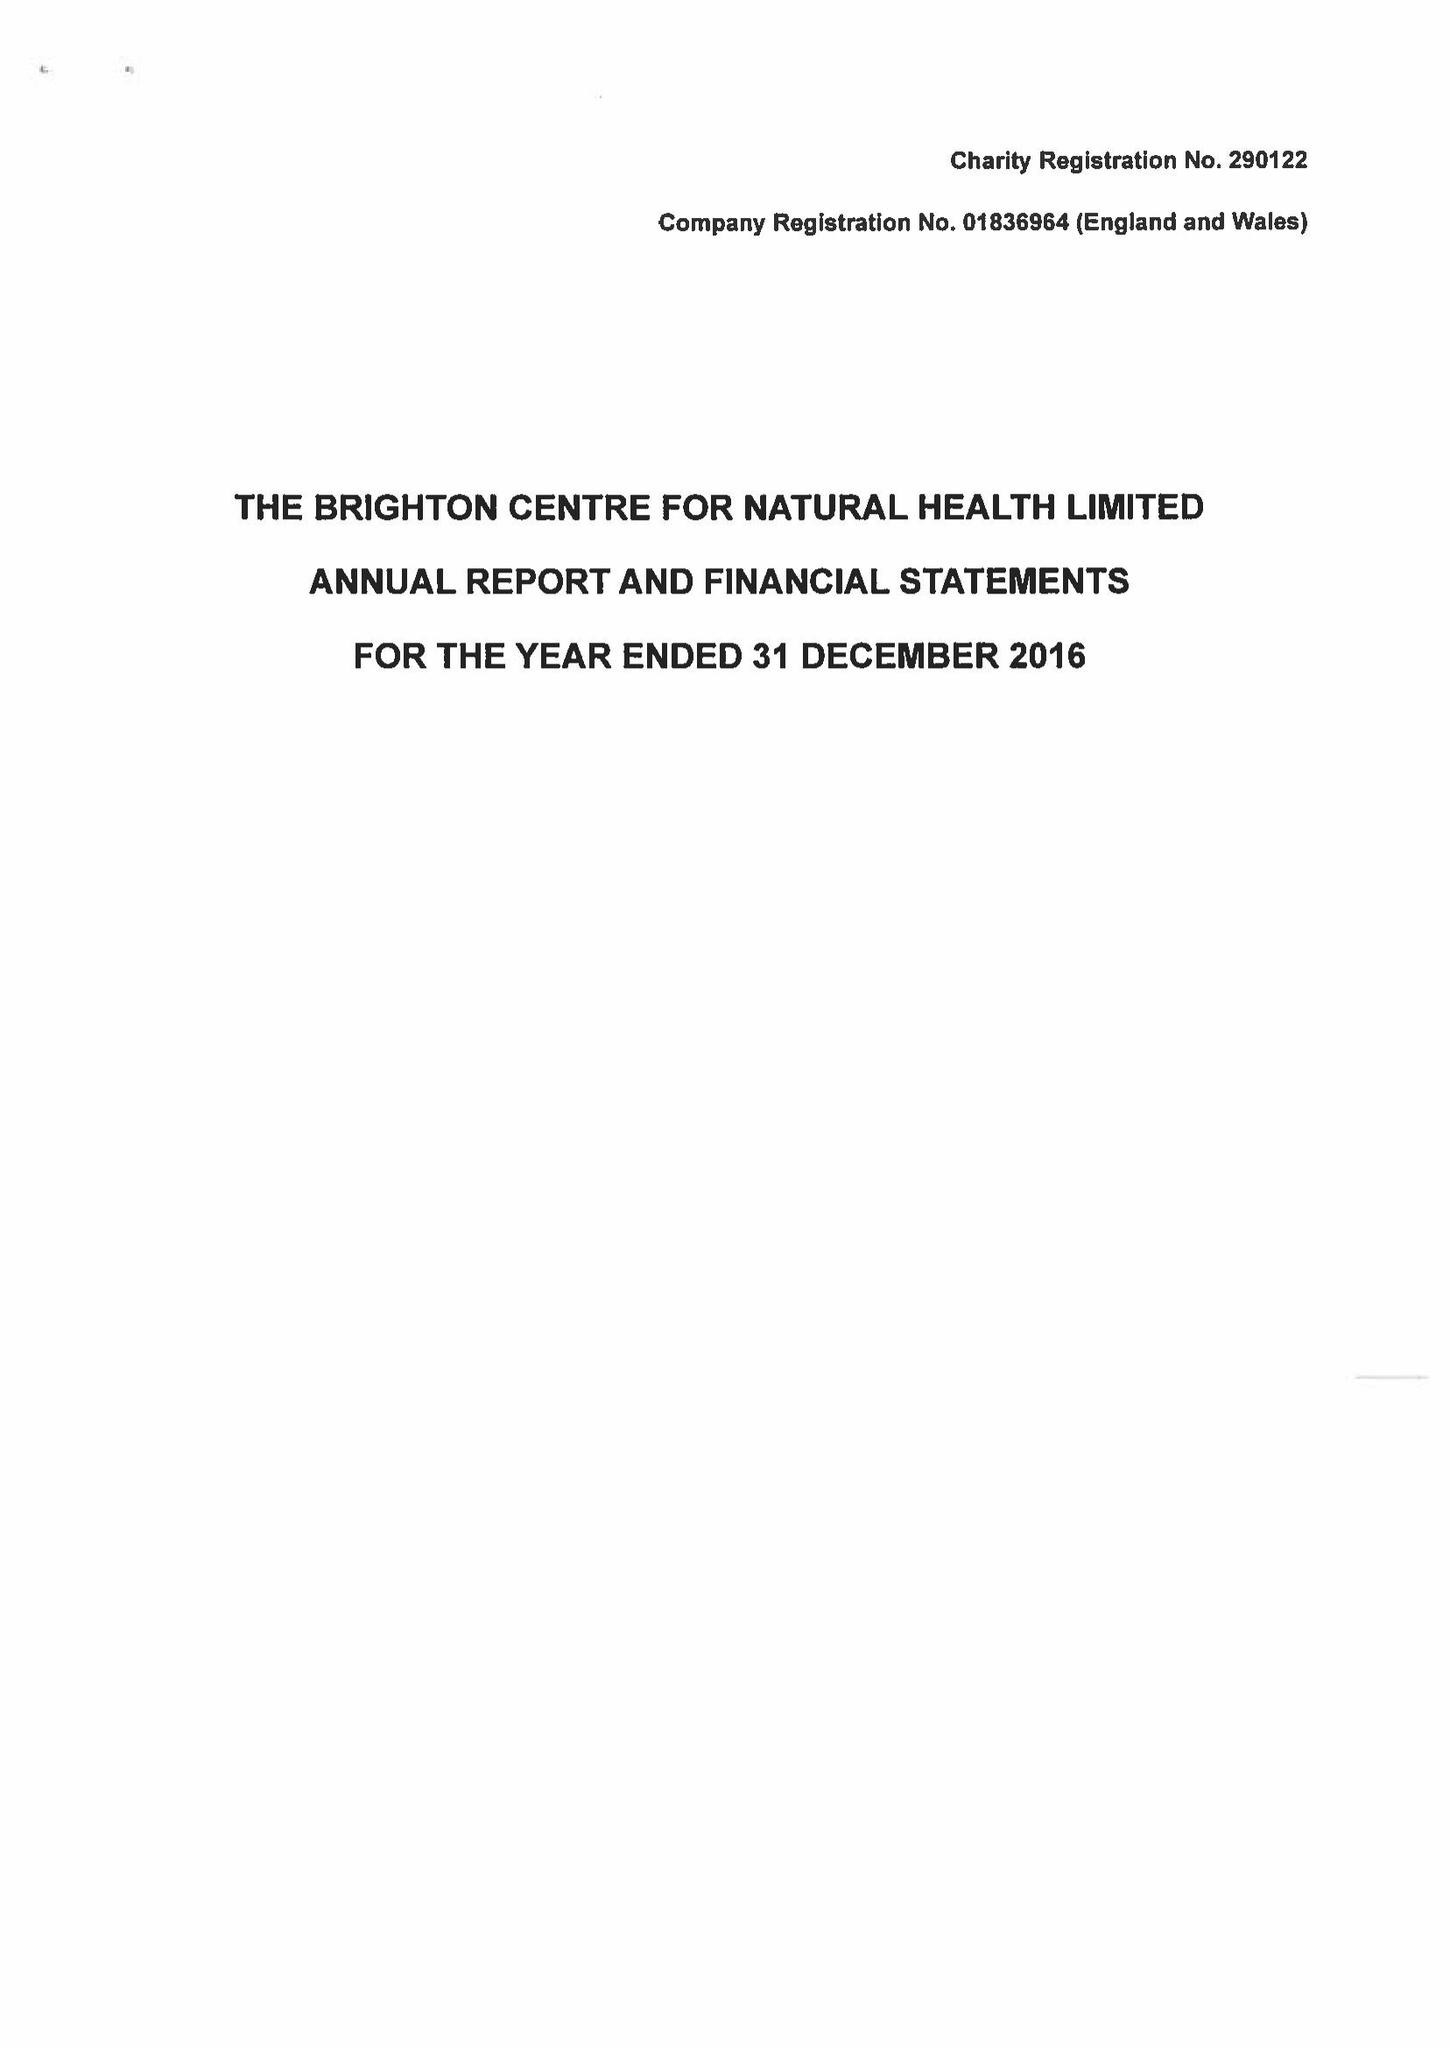What is the value for the charity_number?
Answer the question using a single word or phrase. 290122 